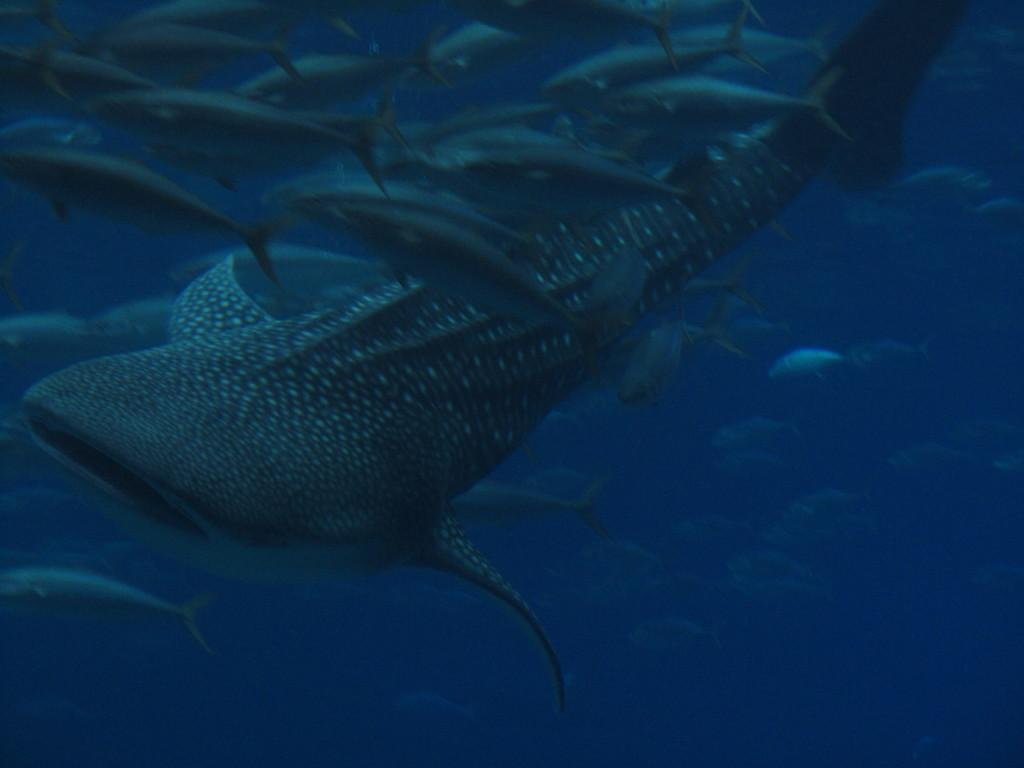What type of animals can be seen in the image? Fish can be seen in the image. Where are the fish located in the image? The fish are under the water in the image. What type of texture can be seen on the fish in the image? There is no specific texture mentioned or visible on the fish in the image. What type of verse can be heard being recited by the fish in the image? There is no indication that the fish are reciting any verses in the image. 